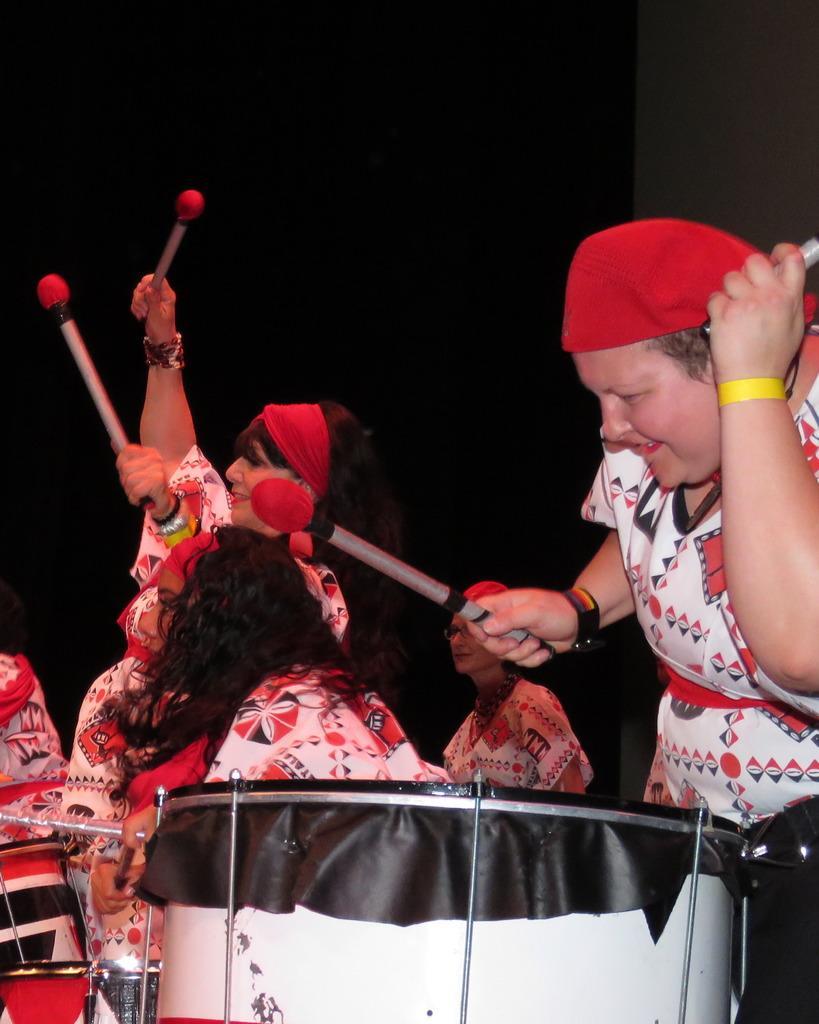Could you give a brief overview of what you see in this image? Here we can see some persons are playing drums. 